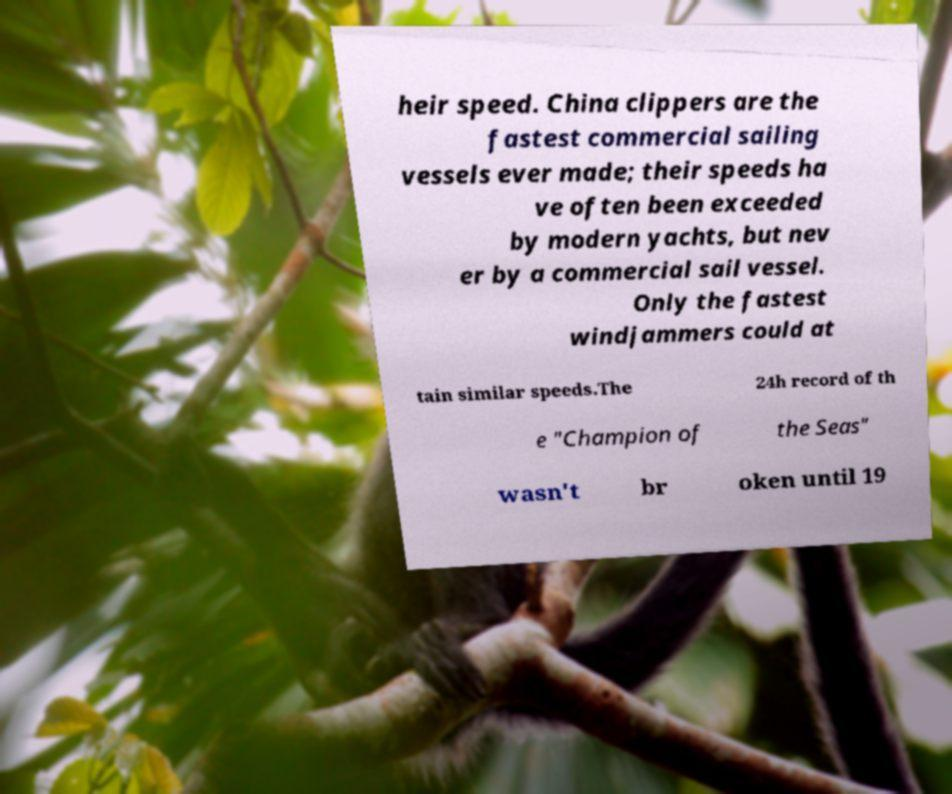Could you assist in decoding the text presented in this image and type it out clearly? heir speed. China clippers are the fastest commercial sailing vessels ever made; their speeds ha ve often been exceeded by modern yachts, but nev er by a commercial sail vessel. Only the fastest windjammers could at tain similar speeds.The 24h record of th e "Champion of the Seas" wasn't br oken until 19 